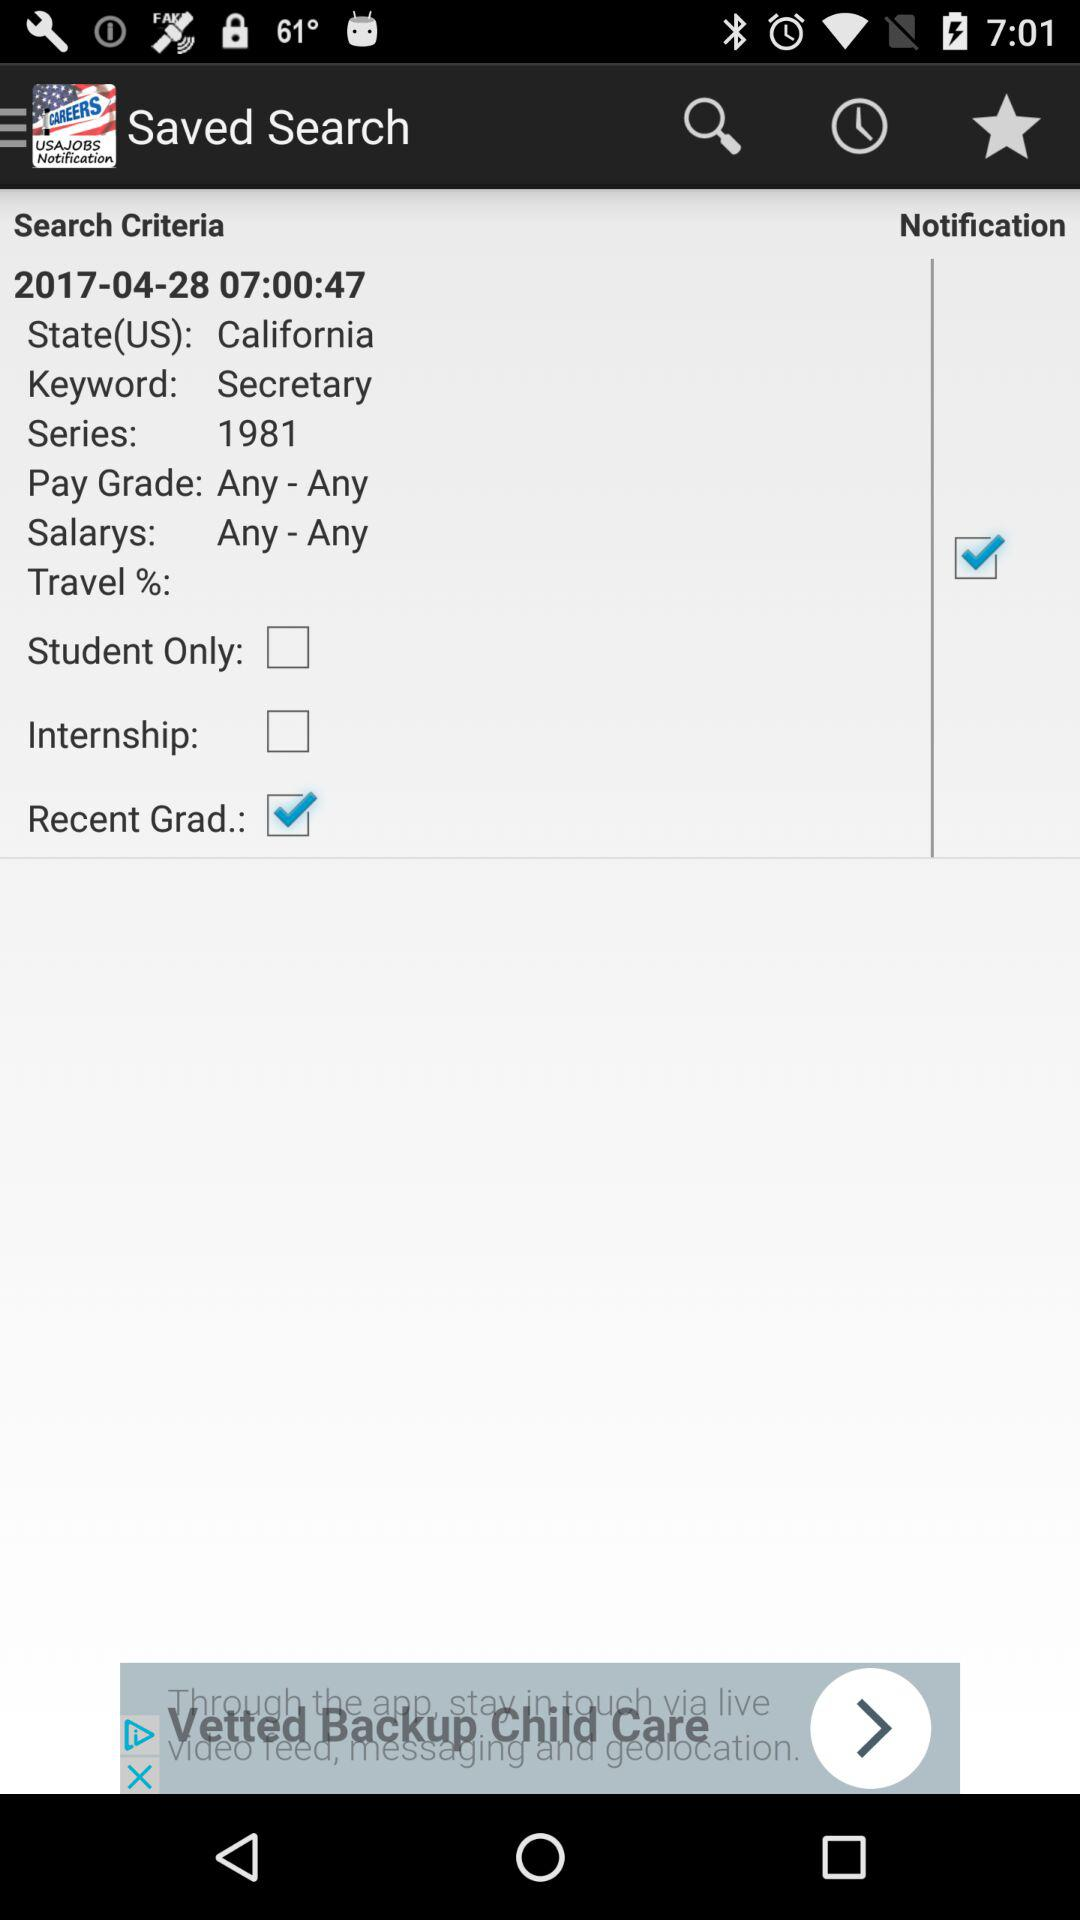Is the internship still active?
When the provided information is insufficient, respond with <no answer>. <no answer> 